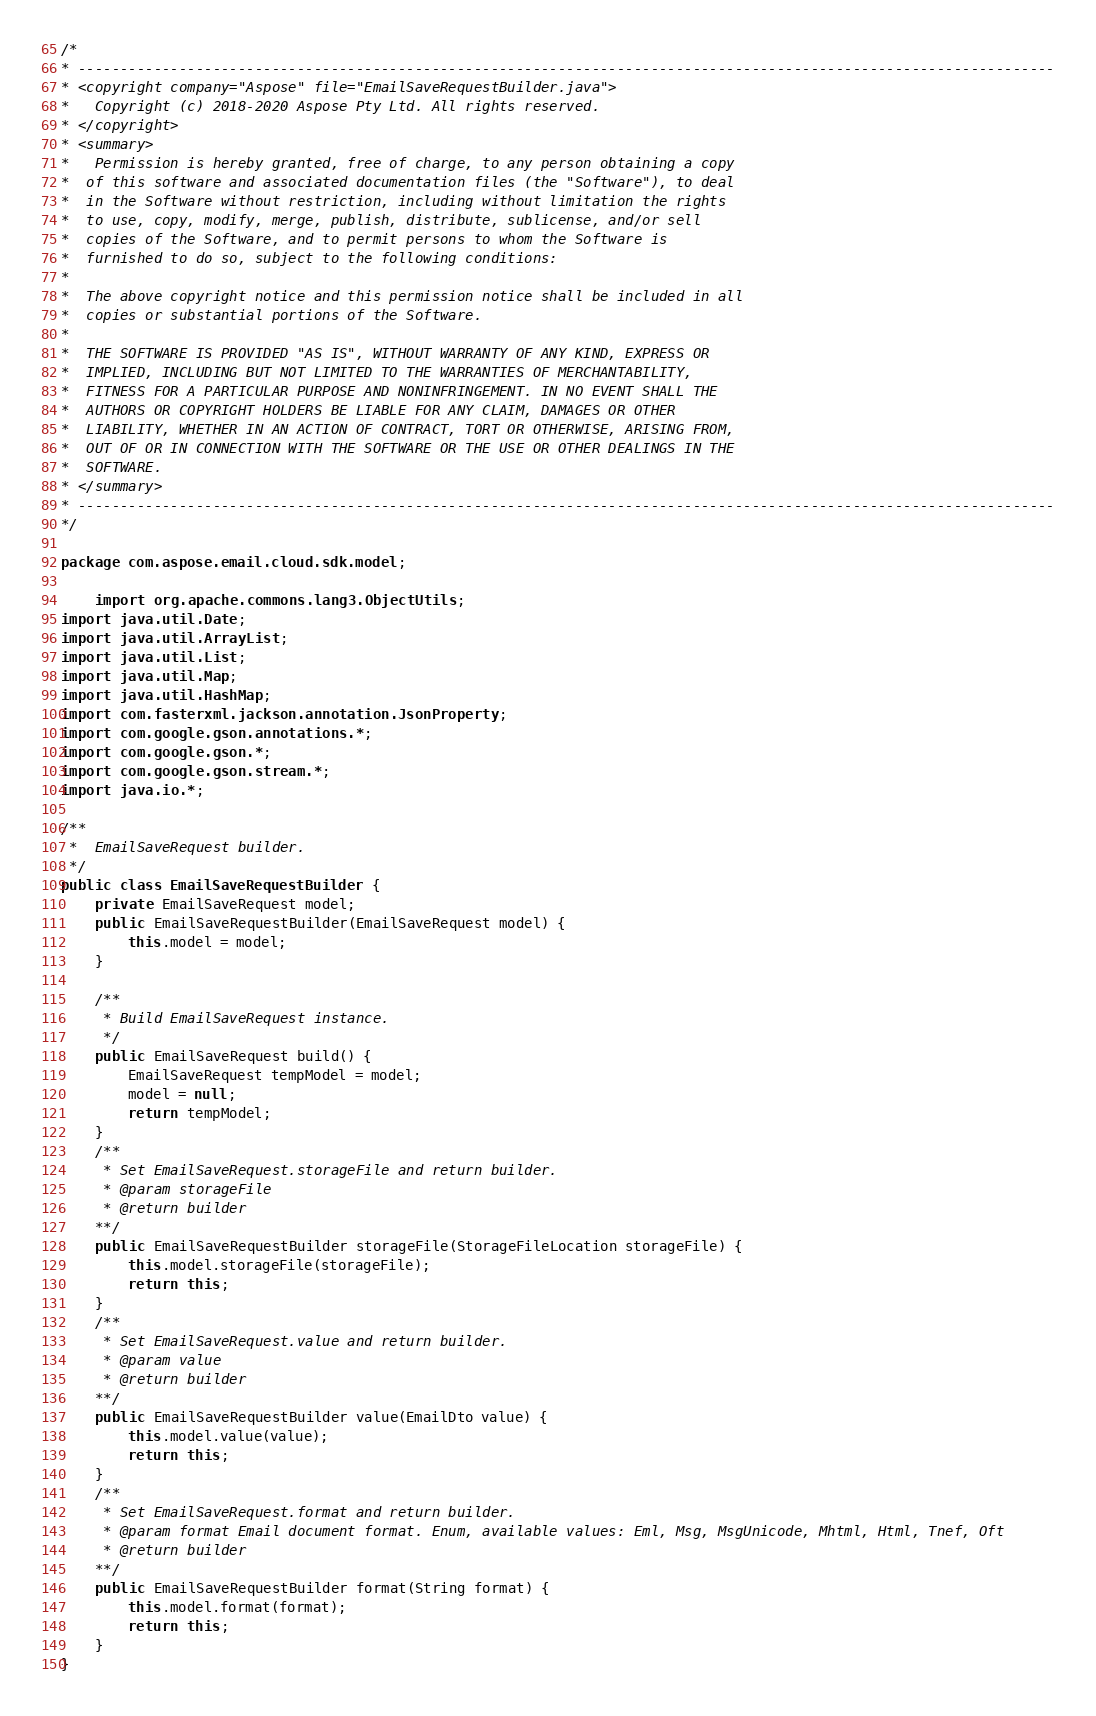Convert code to text. <code><loc_0><loc_0><loc_500><loc_500><_Java_>/*
* --------------------------------------------------------------------------------------------------------------------
* <copyright company="Aspose" file="EmailSaveRequestBuilder.java">
*   Copyright (c) 2018-2020 Aspose Pty Ltd. All rights reserved.
* </copyright>
* <summary>
*   Permission is hereby granted, free of charge, to any person obtaining a copy
*  of this software and associated documentation files (the "Software"), to deal
*  in the Software without restriction, including without limitation the rights
*  to use, copy, modify, merge, publish, distribute, sublicense, and/or sell
*  copies of the Software, and to permit persons to whom the Software is
*  furnished to do so, subject to the following conditions:
* 
*  The above copyright notice and this permission notice shall be included in all
*  copies or substantial portions of the Software.
* 
*  THE SOFTWARE IS PROVIDED "AS IS", WITHOUT WARRANTY OF ANY KIND, EXPRESS OR
*  IMPLIED, INCLUDING BUT NOT LIMITED TO THE WARRANTIES OF MERCHANTABILITY,
*  FITNESS FOR A PARTICULAR PURPOSE AND NONINFRINGEMENT. IN NO EVENT SHALL THE
*  AUTHORS OR COPYRIGHT HOLDERS BE LIABLE FOR ANY CLAIM, DAMAGES OR OTHER
*  LIABILITY, WHETHER IN AN ACTION OF CONTRACT, TORT OR OTHERWISE, ARISING FROM,
*  OUT OF OR IN CONNECTION WITH THE SOFTWARE OR THE USE OR OTHER DEALINGS IN THE
*  SOFTWARE.
* </summary>
* --------------------------------------------------------------------------------------------------------------------
*/

package com.aspose.email.cloud.sdk.model;

    import org.apache.commons.lang3.ObjectUtils;
import java.util.Date;
import java.util.ArrayList;
import java.util.List;
import java.util.Map;
import java.util.HashMap;
import com.fasterxml.jackson.annotation.JsonProperty;
import com.google.gson.annotations.*;
import com.google.gson.*;
import com.google.gson.stream.*;
import java.io.*;

/**
 *  EmailSaveRequest builder.
 */
public class EmailSaveRequestBuilder {
    private EmailSaveRequest model;
    public EmailSaveRequestBuilder(EmailSaveRequest model) {
        this.model = model;
    }

    /**
     * Build EmailSaveRequest instance.
     */
    public EmailSaveRequest build() {
        EmailSaveRequest tempModel = model;
        model = null;
        return tempModel;
    }
    /**
     * Set EmailSaveRequest.storageFile and return builder.
     * @param storageFile 
     * @return builder
    **/
    public EmailSaveRequestBuilder storageFile(StorageFileLocation storageFile) {
        this.model.storageFile(storageFile);
        return this;
    }
    /**
     * Set EmailSaveRequest.value and return builder.
     * @param value 
     * @return builder
    **/
    public EmailSaveRequestBuilder value(EmailDto value) {
        this.model.value(value);
        return this;
    }
    /**
     * Set EmailSaveRequest.format and return builder.
     * @param format Email document format. Enum, available values: Eml, Msg, MsgUnicode, Mhtml, Html, Tnef, Oft
     * @return builder
    **/
    public EmailSaveRequestBuilder format(String format) {
        this.model.format(format);
        return this;
    }
}
</code> 